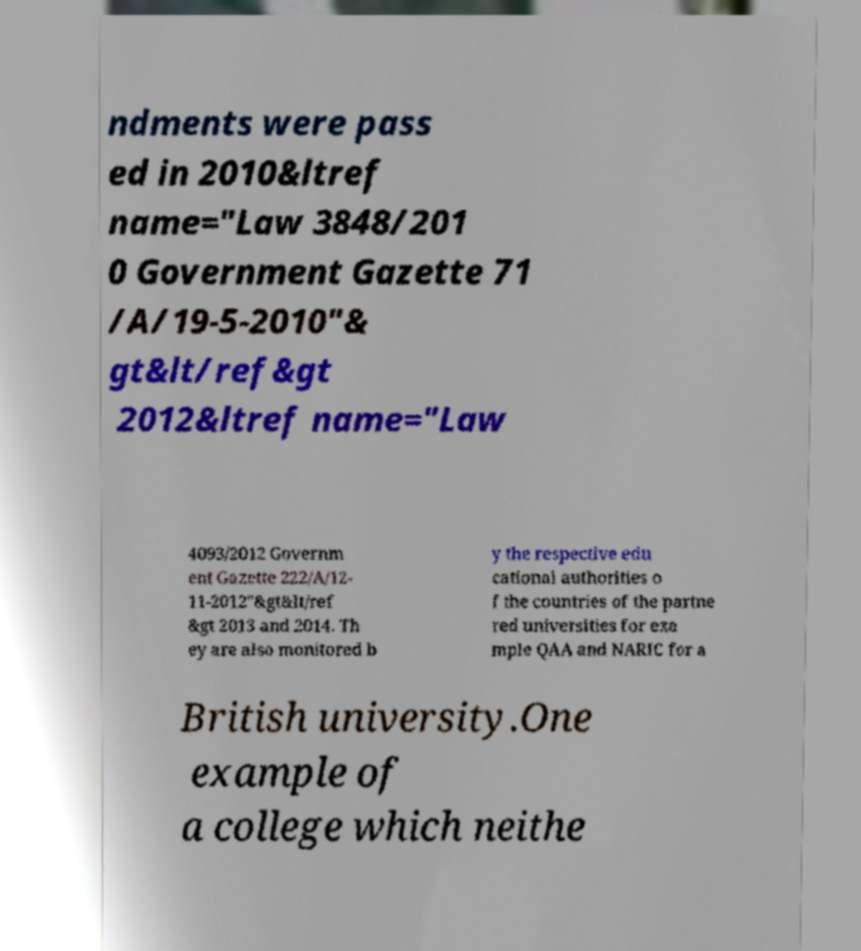For documentation purposes, I need the text within this image transcribed. Could you provide that? ndments were pass ed in 2010&ltref name="Law 3848/201 0 Government Gazette 71 /A/19-5-2010"& gt&lt/ref&gt 2012&ltref name="Law 4093/2012 Governm ent Gazette 222/A/12- 11-2012"&gt&lt/ref &gt 2013 and 2014. Th ey are also monitored b y the respective edu cational authorities o f the countries of the partne red universities for exa mple QAA and NARIC for a British university.One example of a college which neithe 